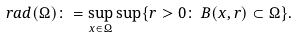<formula> <loc_0><loc_0><loc_500><loc_500>r a d ( \Omega ) \colon = \sup _ { x \in \Omega } \sup \{ r > 0 \colon \, B ( x , r ) \subset \Omega \} .</formula> 